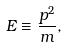Convert formula to latex. <formula><loc_0><loc_0><loc_500><loc_500>E \equiv \frac { p ^ { 2 } } { m } ,</formula> 